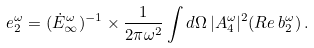Convert formula to latex. <formula><loc_0><loc_0><loc_500><loc_500>e _ { 2 } ^ { \omega } = ( \dot { E } ^ { \omega } _ { \infty } ) ^ { - 1 } \times \frac { 1 } { 2 \pi \omega ^ { 2 } } \int d \Omega \, | A _ { 4 } ^ { \omega } | ^ { 2 } ( { R e } \, b _ { 2 } ^ { \omega } ) \, .</formula> 